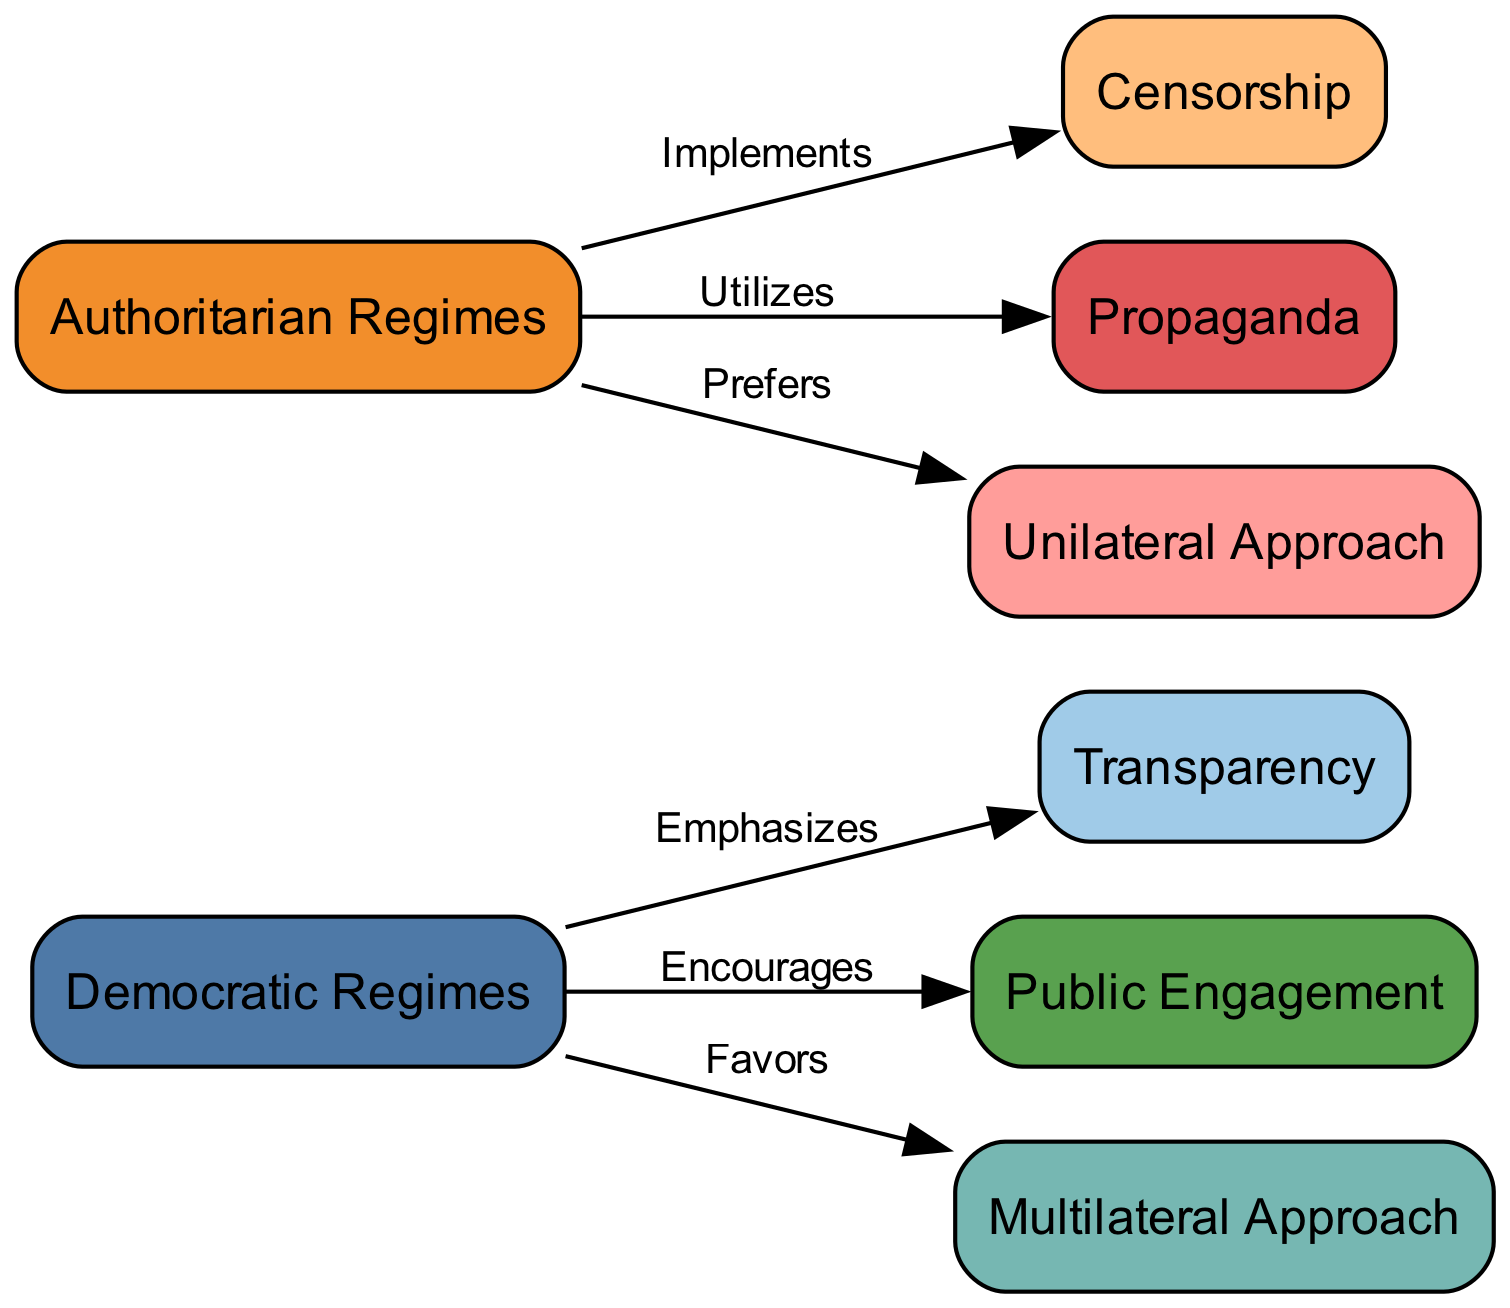What is the total number of nodes in the diagram? The diagram includes eight nodes: democratic regimes, authoritarian regimes, transparency, censorship, public engagement, propaganda, multilateral approach, and unilateral approach. Counting each node gives us a total of eight.
Answer: 8 Which regime emphasizes transparency? The directed edge from democratic regimes to transparency indicates that only democratic regimes emphasize transparency.
Answer: Democratic Regimes What type of approach do authoritarian regimes prefer? The directed edge pointing from authoritarian regimes to unilateral approach indicates that authoritarian regimes prefer this type of approach.
Answer: Unilateral Approach How many edges are connected to democratic regimes? The edges connected to democratic regimes are: it emphasizes transparency, encourages public engagement, and favors multilateral approach. This totals three edges.
Answer: 3 What action is implemented by authoritarian regimes? The diagram shows an edge indicating that authoritarian regimes implement censorship, which is directly linked to that node.
Answer: Censorship What is the relationship between propaganda and authoritarian regimes? There is a directed edge from authoritarian regimes to propaganda, revealing that authoritarian regimes utilize propaganda, indicating a direct connection.
Answer: Utilizes Which approach do democratic regimes favor compared to authoritarian regimes? The directed edge shows that democratic regimes favor a multilateral approach, while authoritarian regimes prefer a unilateral approach. This distinction shows the preference of democratic regimes for collaboration.
Answer: Multilateral Approach What do democratic regimes encourage? The directed edge indicates that democratic regimes encourage public engagement, which is a specific action within their digital diplomacy strategy.
Answer: Public Engagement What strategy do authoritarian regimes depend on to influence public opinion? The diagram illustrates that authoritarian regimes utilize propaganda as a strategy to influence public opinion, shown by the directed edge.
Answer: Propaganda 